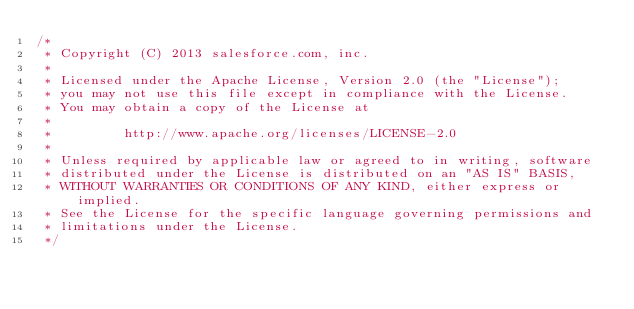Convert code to text. <code><loc_0><loc_0><loc_500><loc_500><_Java_>/*
 * Copyright (C) 2013 salesforce.com, inc.
 *
 * Licensed under the Apache License, Version 2.0 (the "License");
 * you may not use this file except in compliance with the License.
 * You may obtain a copy of the License at
 *
 *         http://www.apache.org/licenses/LICENSE-2.0
 *
 * Unless required by applicable law or agreed to in writing, software
 * distributed under the License is distributed on an "AS IS" BASIS,
 * WITHOUT WARRANTIES OR CONDITIONS OF ANY KIND, either express or implied.
 * See the License for the specific language governing permissions and
 * limitations under the License.
 */</code> 